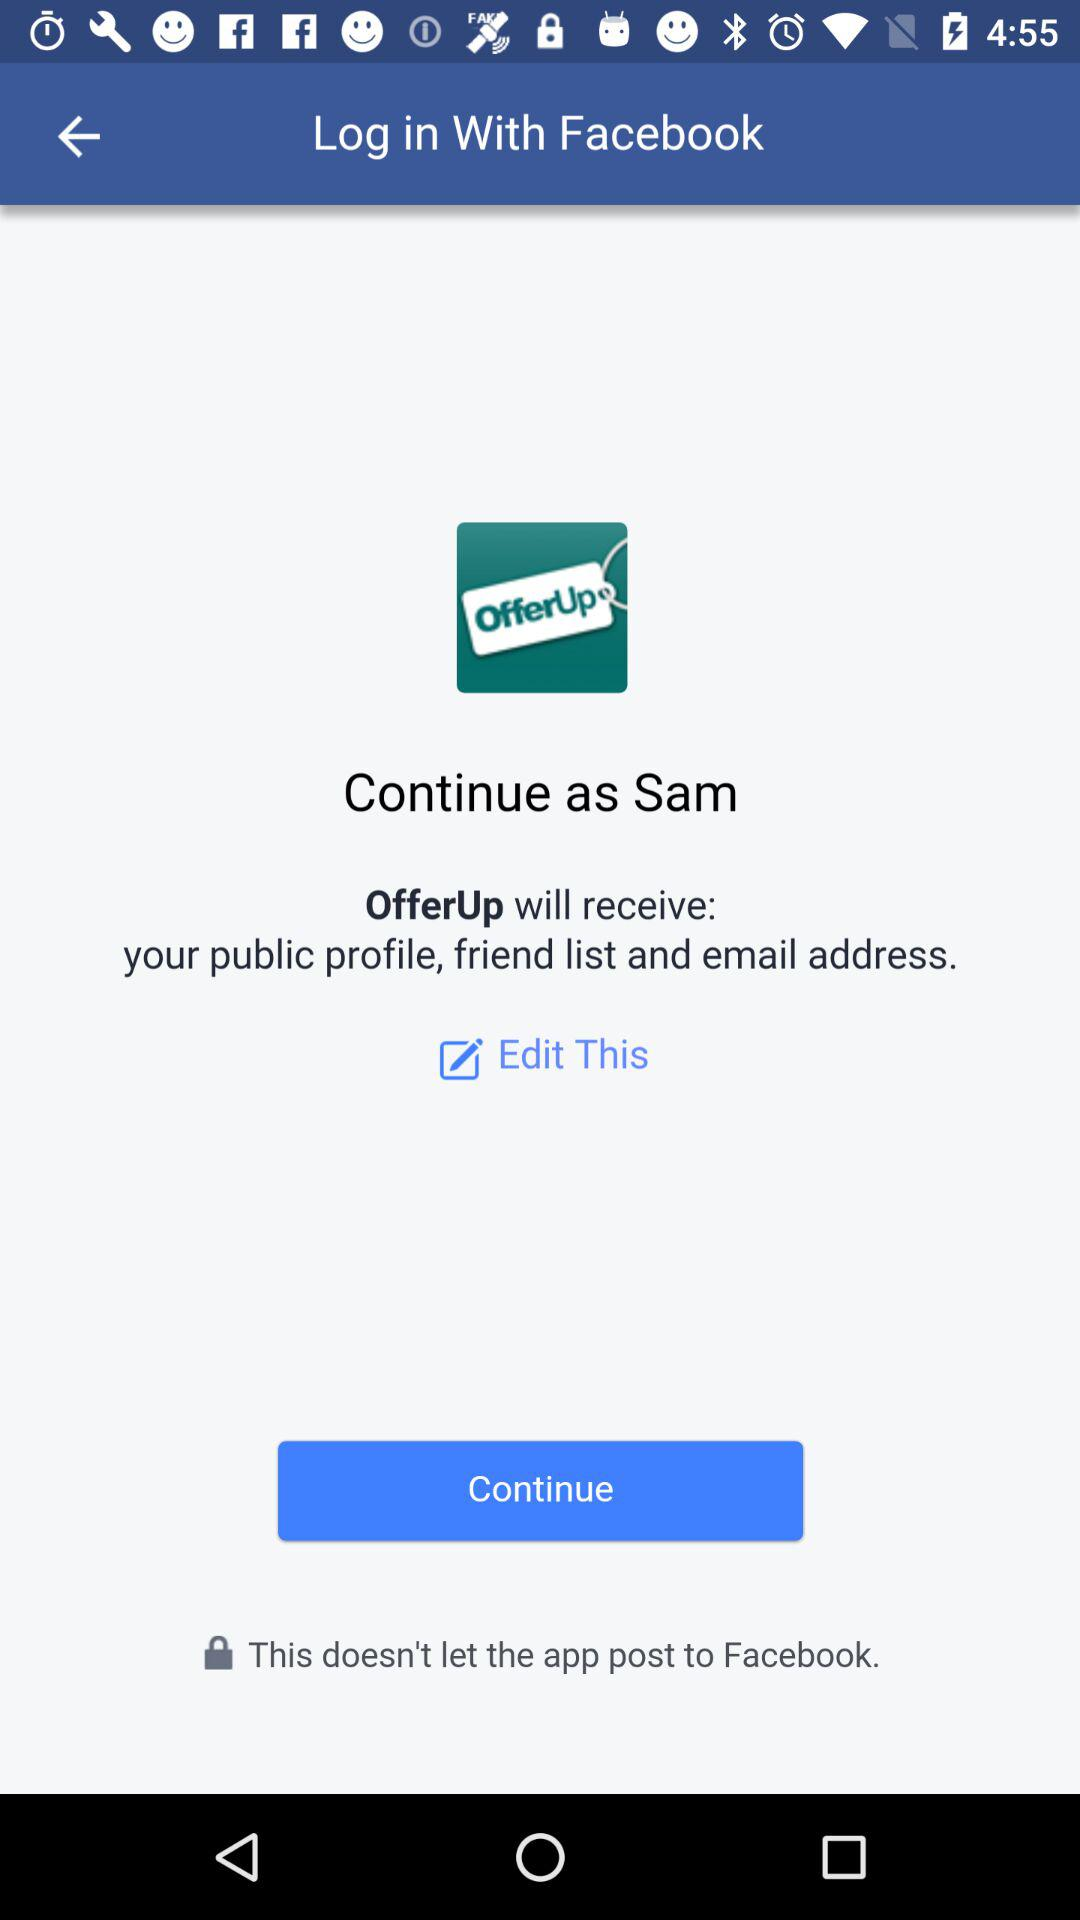What application is asking for permission? The application "OfferUp" is asking for permission. 